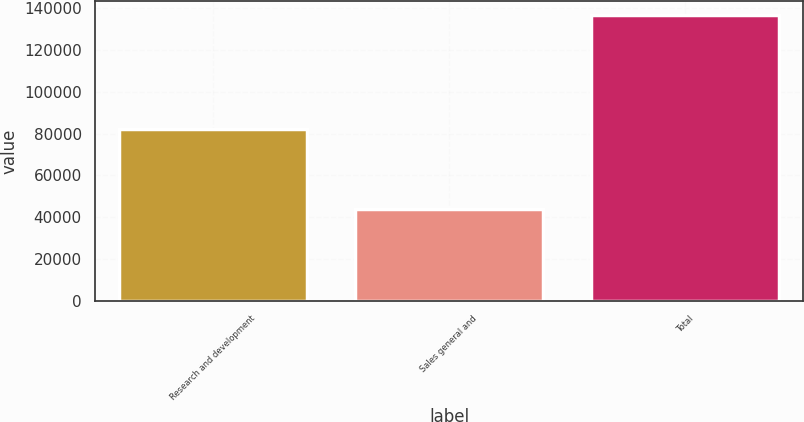Convert chart. <chart><loc_0><loc_0><loc_500><loc_500><bar_chart><fcel>Research and development<fcel>Sales general and<fcel>Total<nl><fcel>82157<fcel>44015<fcel>136662<nl></chart> 